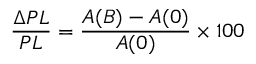<formula> <loc_0><loc_0><loc_500><loc_500>\frac { \Delta P L } { P L } = \frac { A ( B ) - A ( 0 ) } { A ( 0 ) } \times 1 0 0 \</formula> 